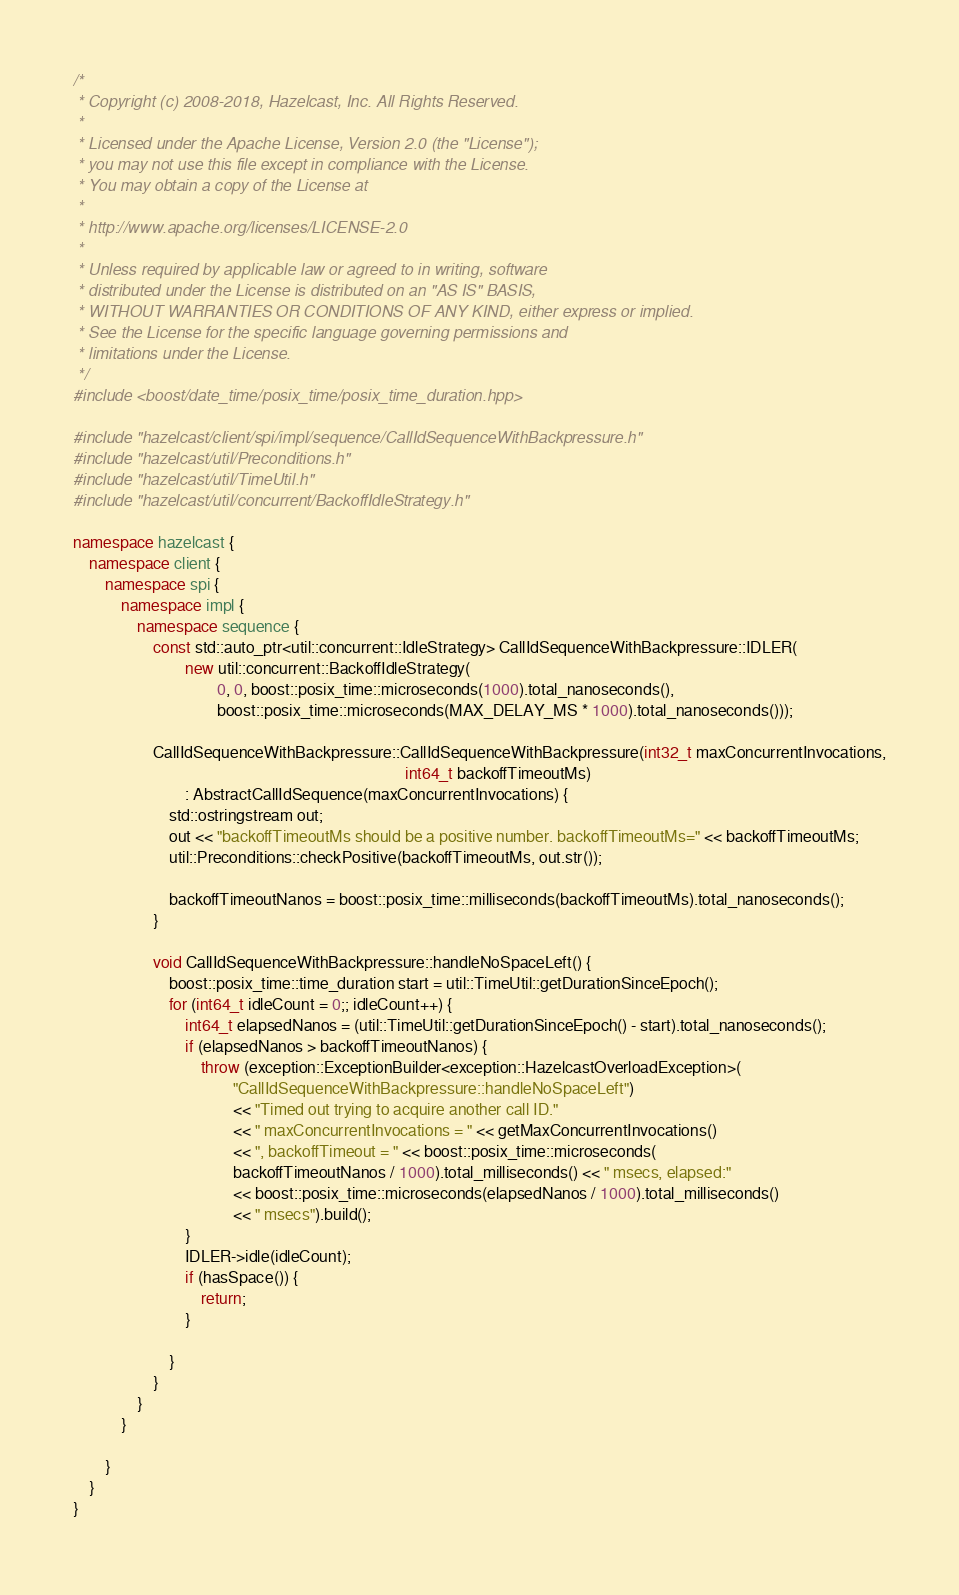Convert code to text. <code><loc_0><loc_0><loc_500><loc_500><_C++_>/*
 * Copyright (c) 2008-2018, Hazelcast, Inc. All Rights Reserved.
 *
 * Licensed under the Apache License, Version 2.0 (the "License");
 * you may not use this file except in compliance with the License.
 * You may obtain a copy of the License at
 *
 * http://www.apache.org/licenses/LICENSE-2.0
 *
 * Unless required by applicable law or agreed to in writing, software
 * distributed under the License is distributed on an "AS IS" BASIS,
 * WITHOUT WARRANTIES OR CONDITIONS OF ANY KIND, either express or implied.
 * See the License for the specific language governing permissions and
 * limitations under the License.
 */
#include <boost/date_time/posix_time/posix_time_duration.hpp>

#include "hazelcast/client/spi/impl/sequence/CallIdSequenceWithBackpressure.h"
#include "hazelcast/util/Preconditions.h"
#include "hazelcast/util/TimeUtil.h"
#include "hazelcast/util/concurrent/BackoffIdleStrategy.h"

namespace hazelcast {
    namespace client {
        namespace spi {
            namespace impl {
                namespace sequence {
                    const std::auto_ptr<util::concurrent::IdleStrategy> CallIdSequenceWithBackpressure::IDLER(
                            new util::concurrent::BackoffIdleStrategy(
                                    0, 0, boost::posix_time::microseconds(1000).total_nanoseconds(),
                                    boost::posix_time::microseconds(MAX_DELAY_MS * 1000).total_nanoseconds()));

                    CallIdSequenceWithBackpressure::CallIdSequenceWithBackpressure(int32_t maxConcurrentInvocations,
                                                                                   int64_t backoffTimeoutMs)
                            : AbstractCallIdSequence(maxConcurrentInvocations) {
                        std::ostringstream out;
                        out << "backoffTimeoutMs should be a positive number. backoffTimeoutMs=" << backoffTimeoutMs;
                        util::Preconditions::checkPositive(backoffTimeoutMs, out.str());

                        backoffTimeoutNanos = boost::posix_time::milliseconds(backoffTimeoutMs).total_nanoseconds();
                    }

                    void CallIdSequenceWithBackpressure::handleNoSpaceLeft() {
                        boost::posix_time::time_duration start = util::TimeUtil::getDurationSinceEpoch();
                        for (int64_t idleCount = 0;; idleCount++) {
                            int64_t elapsedNanos = (util::TimeUtil::getDurationSinceEpoch() - start).total_nanoseconds();
                            if (elapsedNanos > backoffTimeoutNanos) {
                                throw (exception::ExceptionBuilder<exception::HazelcastOverloadException>(
                                        "CallIdSequenceWithBackpressure::handleNoSpaceLeft")
                                        << "Timed out trying to acquire another call ID."
                                        << " maxConcurrentInvocations = " << getMaxConcurrentInvocations()
                                        << ", backoffTimeout = " << boost::posix_time::microseconds(
                                        backoffTimeoutNanos / 1000).total_milliseconds() << " msecs, elapsed:"
                                        << boost::posix_time::microseconds(elapsedNanos / 1000).total_milliseconds()
                                        << " msecs").build();
                            }
                            IDLER->idle(idleCount);
                            if (hasSpace()) {
                                return;
                            }

                        }
                    }
                }
            }

        }
    }
}
</code> 